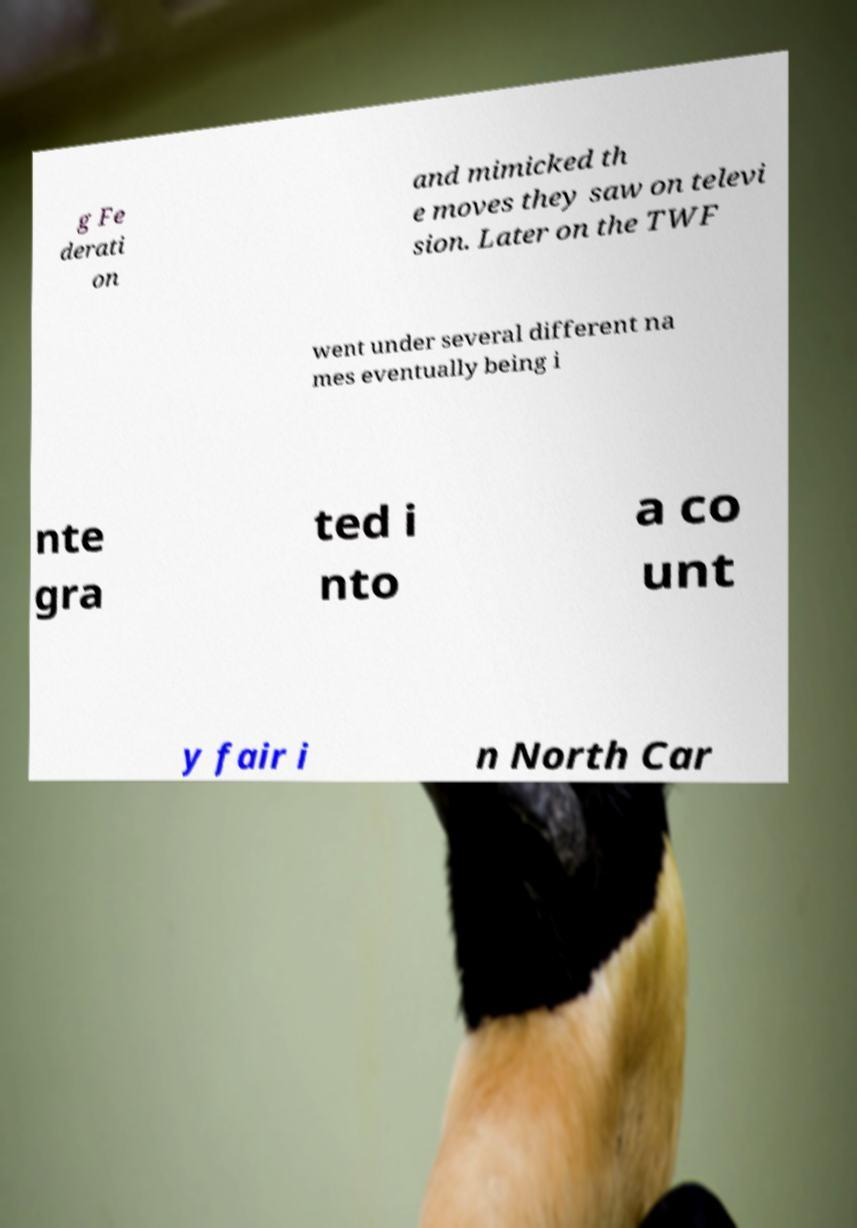Could you extract and type out the text from this image? g Fe derati on and mimicked th e moves they saw on televi sion. Later on the TWF went under several different na mes eventually being i nte gra ted i nto a co unt y fair i n North Car 